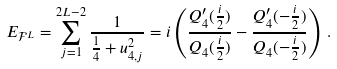<formula> <loc_0><loc_0><loc_500><loc_500>E _ { \mathcal { F } ^ { L } } = \sum ^ { 2 L - 2 } _ { j = 1 } \frac { 1 } { \frac { 1 } { 4 } + u _ { 4 , j } ^ { 2 } } = i \left ( \frac { Q _ { 4 } ^ { \prime } ( \frac { i } { 2 } ) } { Q _ { 4 } ( \frac { i } { 2 } ) } - \frac { Q _ { 4 } ^ { \prime } ( - \frac { i } { 2 } ) } { Q _ { 4 } ( - \frac { i } { 2 } ) } \right ) \, .</formula> 